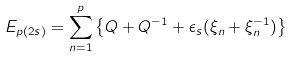<formula> <loc_0><loc_0><loc_500><loc_500>E _ { p ( 2 s ) } = \sum _ { n = 1 } ^ { p } \left \{ Q + Q ^ { - 1 } + \epsilon _ { s } ( \xi _ { n } + \xi _ { n } ^ { - 1 } ) \right \}</formula> 